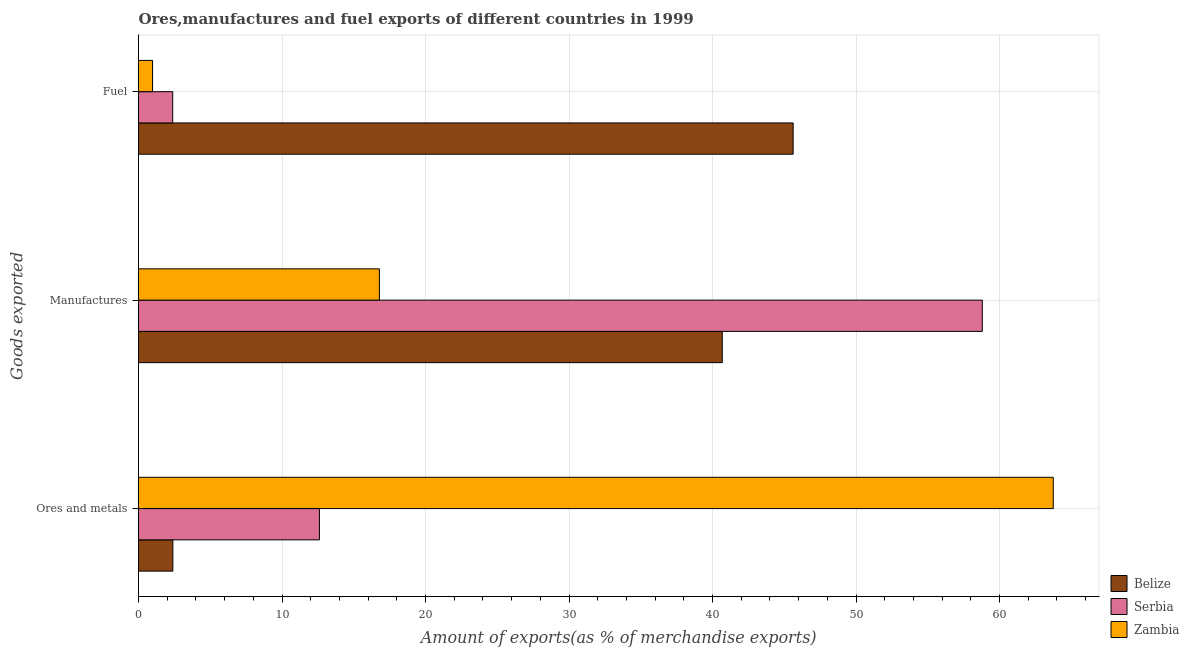How many different coloured bars are there?
Make the answer very short. 3. How many groups of bars are there?
Provide a short and direct response. 3. Are the number of bars on each tick of the Y-axis equal?
Keep it short and to the point. Yes. How many bars are there on the 3rd tick from the top?
Your answer should be very brief. 3. How many bars are there on the 3rd tick from the bottom?
Your answer should be very brief. 3. What is the label of the 2nd group of bars from the top?
Offer a very short reply. Manufactures. What is the percentage of manufactures exports in Belize?
Your response must be concise. 40.68. Across all countries, what is the maximum percentage of ores and metals exports?
Ensure brevity in your answer.  63.74. Across all countries, what is the minimum percentage of ores and metals exports?
Your response must be concise. 2.39. In which country was the percentage of ores and metals exports maximum?
Give a very brief answer. Zambia. In which country was the percentage of fuel exports minimum?
Provide a succinct answer. Zambia. What is the total percentage of ores and metals exports in the graph?
Keep it short and to the point. 78.74. What is the difference between the percentage of manufactures exports in Zambia and that in Serbia?
Your answer should be very brief. -42.01. What is the difference between the percentage of manufactures exports in Belize and the percentage of fuel exports in Serbia?
Keep it short and to the point. 38.29. What is the average percentage of ores and metals exports per country?
Provide a succinct answer. 26.25. What is the difference between the percentage of fuel exports and percentage of manufactures exports in Belize?
Make the answer very short. 4.94. What is the ratio of the percentage of ores and metals exports in Serbia to that in Zambia?
Keep it short and to the point. 0.2. What is the difference between the highest and the second highest percentage of fuel exports?
Provide a short and direct response. 43.23. What is the difference between the highest and the lowest percentage of ores and metals exports?
Provide a short and direct response. 61.35. In how many countries, is the percentage of manufactures exports greater than the average percentage of manufactures exports taken over all countries?
Keep it short and to the point. 2. Is the sum of the percentage of ores and metals exports in Zambia and Belize greater than the maximum percentage of fuel exports across all countries?
Provide a short and direct response. Yes. What does the 2nd bar from the top in Ores and metals represents?
Give a very brief answer. Serbia. What does the 2nd bar from the bottom in Manufactures represents?
Provide a succinct answer. Serbia. Is it the case that in every country, the sum of the percentage of ores and metals exports and percentage of manufactures exports is greater than the percentage of fuel exports?
Offer a very short reply. No. How many bars are there?
Provide a succinct answer. 9. How many countries are there in the graph?
Keep it short and to the point. 3. Are the values on the major ticks of X-axis written in scientific E-notation?
Ensure brevity in your answer.  No. Does the graph contain grids?
Your answer should be very brief. Yes. How many legend labels are there?
Your response must be concise. 3. What is the title of the graph?
Provide a short and direct response. Ores,manufactures and fuel exports of different countries in 1999. Does "Swaziland" appear as one of the legend labels in the graph?
Keep it short and to the point. No. What is the label or title of the X-axis?
Your answer should be very brief. Amount of exports(as % of merchandise exports). What is the label or title of the Y-axis?
Offer a terse response. Goods exported. What is the Amount of exports(as % of merchandise exports) of Belize in Ores and metals?
Your answer should be very brief. 2.39. What is the Amount of exports(as % of merchandise exports) of Serbia in Ores and metals?
Provide a short and direct response. 12.61. What is the Amount of exports(as % of merchandise exports) in Zambia in Ores and metals?
Keep it short and to the point. 63.74. What is the Amount of exports(as % of merchandise exports) in Belize in Manufactures?
Provide a succinct answer. 40.68. What is the Amount of exports(as % of merchandise exports) in Serbia in Manufactures?
Your response must be concise. 58.8. What is the Amount of exports(as % of merchandise exports) in Zambia in Manufactures?
Ensure brevity in your answer.  16.79. What is the Amount of exports(as % of merchandise exports) of Belize in Fuel?
Make the answer very short. 45.62. What is the Amount of exports(as % of merchandise exports) in Serbia in Fuel?
Ensure brevity in your answer.  2.38. What is the Amount of exports(as % of merchandise exports) in Zambia in Fuel?
Ensure brevity in your answer.  0.98. Across all Goods exported, what is the maximum Amount of exports(as % of merchandise exports) in Belize?
Your answer should be very brief. 45.62. Across all Goods exported, what is the maximum Amount of exports(as % of merchandise exports) of Serbia?
Ensure brevity in your answer.  58.8. Across all Goods exported, what is the maximum Amount of exports(as % of merchandise exports) in Zambia?
Offer a very short reply. 63.74. Across all Goods exported, what is the minimum Amount of exports(as % of merchandise exports) of Belize?
Your answer should be very brief. 2.39. Across all Goods exported, what is the minimum Amount of exports(as % of merchandise exports) in Serbia?
Your answer should be very brief. 2.38. Across all Goods exported, what is the minimum Amount of exports(as % of merchandise exports) in Zambia?
Ensure brevity in your answer.  0.98. What is the total Amount of exports(as % of merchandise exports) of Belize in the graph?
Provide a succinct answer. 88.69. What is the total Amount of exports(as % of merchandise exports) in Serbia in the graph?
Offer a very short reply. 73.79. What is the total Amount of exports(as % of merchandise exports) of Zambia in the graph?
Give a very brief answer. 81.51. What is the difference between the Amount of exports(as % of merchandise exports) of Belize in Ores and metals and that in Manufactures?
Offer a very short reply. -38.28. What is the difference between the Amount of exports(as % of merchandise exports) of Serbia in Ores and metals and that in Manufactures?
Offer a very short reply. -46.19. What is the difference between the Amount of exports(as % of merchandise exports) of Zambia in Ores and metals and that in Manufactures?
Offer a very short reply. 46.96. What is the difference between the Amount of exports(as % of merchandise exports) of Belize in Ores and metals and that in Fuel?
Provide a short and direct response. -43.22. What is the difference between the Amount of exports(as % of merchandise exports) in Serbia in Ores and metals and that in Fuel?
Your response must be concise. 10.22. What is the difference between the Amount of exports(as % of merchandise exports) in Zambia in Ores and metals and that in Fuel?
Keep it short and to the point. 62.76. What is the difference between the Amount of exports(as % of merchandise exports) of Belize in Manufactures and that in Fuel?
Keep it short and to the point. -4.94. What is the difference between the Amount of exports(as % of merchandise exports) in Serbia in Manufactures and that in Fuel?
Your response must be concise. 56.41. What is the difference between the Amount of exports(as % of merchandise exports) of Zambia in Manufactures and that in Fuel?
Give a very brief answer. 15.81. What is the difference between the Amount of exports(as % of merchandise exports) of Belize in Ores and metals and the Amount of exports(as % of merchandise exports) of Serbia in Manufactures?
Make the answer very short. -56.4. What is the difference between the Amount of exports(as % of merchandise exports) in Belize in Ores and metals and the Amount of exports(as % of merchandise exports) in Zambia in Manufactures?
Your answer should be very brief. -14.39. What is the difference between the Amount of exports(as % of merchandise exports) in Serbia in Ores and metals and the Amount of exports(as % of merchandise exports) in Zambia in Manufactures?
Provide a succinct answer. -4.18. What is the difference between the Amount of exports(as % of merchandise exports) in Belize in Ores and metals and the Amount of exports(as % of merchandise exports) in Zambia in Fuel?
Give a very brief answer. 1.41. What is the difference between the Amount of exports(as % of merchandise exports) of Serbia in Ores and metals and the Amount of exports(as % of merchandise exports) of Zambia in Fuel?
Offer a very short reply. 11.63. What is the difference between the Amount of exports(as % of merchandise exports) of Belize in Manufactures and the Amount of exports(as % of merchandise exports) of Serbia in Fuel?
Your answer should be very brief. 38.29. What is the difference between the Amount of exports(as % of merchandise exports) in Belize in Manufactures and the Amount of exports(as % of merchandise exports) in Zambia in Fuel?
Keep it short and to the point. 39.7. What is the difference between the Amount of exports(as % of merchandise exports) in Serbia in Manufactures and the Amount of exports(as % of merchandise exports) in Zambia in Fuel?
Ensure brevity in your answer.  57.82. What is the average Amount of exports(as % of merchandise exports) of Belize per Goods exported?
Your response must be concise. 29.56. What is the average Amount of exports(as % of merchandise exports) in Serbia per Goods exported?
Provide a succinct answer. 24.6. What is the average Amount of exports(as % of merchandise exports) in Zambia per Goods exported?
Offer a terse response. 27.17. What is the difference between the Amount of exports(as % of merchandise exports) in Belize and Amount of exports(as % of merchandise exports) in Serbia in Ores and metals?
Offer a very short reply. -10.21. What is the difference between the Amount of exports(as % of merchandise exports) of Belize and Amount of exports(as % of merchandise exports) of Zambia in Ores and metals?
Your answer should be compact. -61.35. What is the difference between the Amount of exports(as % of merchandise exports) in Serbia and Amount of exports(as % of merchandise exports) in Zambia in Ores and metals?
Keep it short and to the point. -51.14. What is the difference between the Amount of exports(as % of merchandise exports) of Belize and Amount of exports(as % of merchandise exports) of Serbia in Manufactures?
Provide a succinct answer. -18.12. What is the difference between the Amount of exports(as % of merchandise exports) in Belize and Amount of exports(as % of merchandise exports) in Zambia in Manufactures?
Offer a very short reply. 23.89. What is the difference between the Amount of exports(as % of merchandise exports) of Serbia and Amount of exports(as % of merchandise exports) of Zambia in Manufactures?
Make the answer very short. 42.01. What is the difference between the Amount of exports(as % of merchandise exports) in Belize and Amount of exports(as % of merchandise exports) in Serbia in Fuel?
Make the answer very short. 43.23. What is the difference between the Amount of exports(as % of merchandise exports) in Belize and Amount of exports(as % of merchandise exports) in Zambia in Fuel?
Make the answer very short. 44.64. What is the difference between the Amount of exports(as % of merchandise exports) in Serbia and Amount of exports(as % of merchandise exports) in Zambia in Fuel?
Give a very brief answer. 1.4. What is the ratio of the Amount of exports(as % of merchandise exports) of Belize in Ores and metals to that in Manufactures?
Your answer should be compact. 0.06. What is the ratio of the Amount of exports(as % of merchandise exports) in Serbia in Ores and metals to that in Manufactures?
Keep it short and to the point. 0.21. What is the ratio of the Amount of exports(as % of merchandise exports) of Zambia in Ores and metals to that in Manufactures?
Make the answer very short. 3.8. What is the ratio of the Amount of exports(as % of merchandise exports) in Belize in Ores and metals to that in Fuel?
Your response must be concise. 0.05. What is the ratio of the Amount of exports(as % of merchandise exports) in Serbia in Ores and metals to that in Fuel?
Your answer should be compact. 5.29. What is the ratio of the Amount of exports(as % of merchandise exports) of Zambia in Ores and metals to that in Fuel?
Provide a short and direct response. 65.07. What is the ratio of the Amount of exports(as % of merchandise exports) in Belize in Manufactures to that in Fuel?
Ensure brevity in your answer.  0.89. What is the ratio of the Amount of exports(as % of merchandise exports) in Serbia in Manufactures to that in Fuel?
Make the answer very short. 24.67. What is the ratio of the Amount of exports(as % of merchandise exports) of Zambia in Manufactures to that in Fuel?
Keep it short and to the point. 17.14. What is the difference between the highest and the second highest Amount of exports(as % of merchandise exports) of Belize?
Your answer should be compact. 4.94. What is the difference between the highest and the second highest Amount of exports(as % of merchandise exports) in Serbia?
Keep it short and to the point. 46.19. What is the difference between the highest and the second highest Amount of exports(as % of merchandise exports) of Zambia?
Give a very brief answer. 46.96. What is the difference between the highest and the lowest Amount of exports(as % of merchandise exports) of Belize?
Offer a very short reply. 43.22. What is the difference between the highest and the lowest Amount of exports(as % of merchandise exports) in Serbia?
Your answer should be compact. 56.41. What is the difference between the highest and the lowest Amount of exports(as % of merchandise exports) in Zambia?
Your response must be concise. 62.76. 